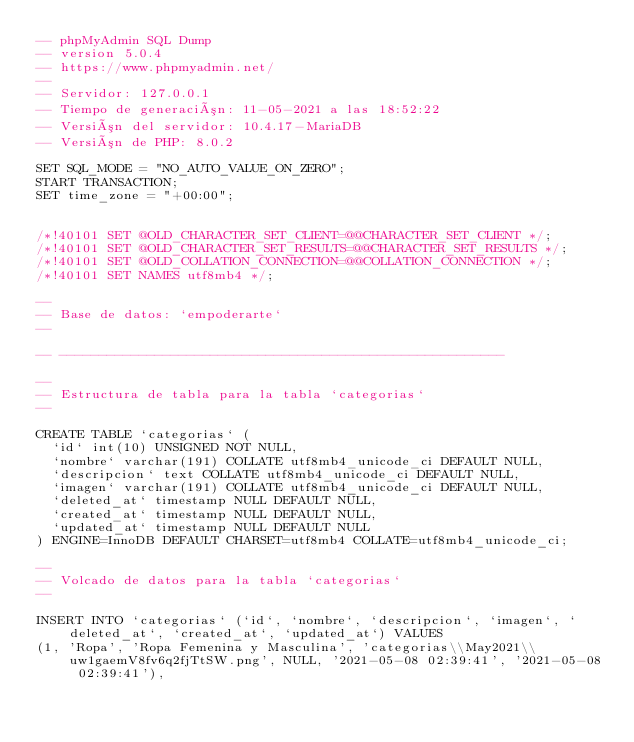<code> <loc_0><loc_0><loc_500><loc_500><_SQL_>-- phpMyAdmin SQL Dump
-- version 5.0.4
-- https://www.phpmyadmin.net/
--
-- Servidor: 127.0.0.1
-- Tiempo de generación: 11-05-2021 a las 18:52:22
-- Versión del servidor: 10.4.17-MariaDB
-- Versión de PHP: 8.0.2

SET SQL_MODE = "NO_AUTO_VALUE_ON_ZERO";
START TRANSACTION;
SET time_zone = "+00:00";


/*!40101 SET @OLD_CHARACTER_SET_CLIENT=@@CHARACTER_SET_CLIENT */;
/*!40101 SET @OLD_CHARACTER_SET_RESULTS=@@CHARACTER_SET_RESULTS */;
/*!40101 SET @OLD_COLLATION_CONNECTION=@@COLLATION_CONNECTION */;
/*!40101 SET NAMES utf8mb4 */;

--
-- Base de datos: `empoderarte`
--

-- --------------------------------------------------------

--
-- Estructura de tabla para la tabla `categorias`
--

CREATE TABLE `categorias` (
  `id` int(10) UNSIGNED NOT NULL,
  `nombre` varchar(191) COLLATE utf8mb4_unicode_ci DEFAULT NULL,
  `descripcion` text COLLATE utf8mb4_unicode_ci DEFAULT NULL,
  `imagen` varchar(191) COLLATE utf8mb4_unicode_ci DEFAULT NULL,
  `deleted_at` timestamp NULL DEFAULT NULL,
  `created_at` timestamp NULL DEFAULT NULL,
  `updated_at` timestamp NULL DEFAULT NULL
) ENGINE=InnoDB DEFAULT CHARSET=utf8mb4 COLLATE=utf8mb4_unicode_ci;

--
-- Volcado de datos para la tabla `categorias`
--

INSERT INTO `categorias` (`id`, `nombre`, `descripcion`, `imagen`, `deleted_at`, `created_at`, `updated_at`) VALUES
(1, 'Ropa', 'Ropa Femenina y Masculina', 'categorias\\May2021\\uw1gaemV8fv6q2fjTtSW.png', NULL, '2021-05-08 02:39:41', '2021-05-08 02:39:41'),</code> 